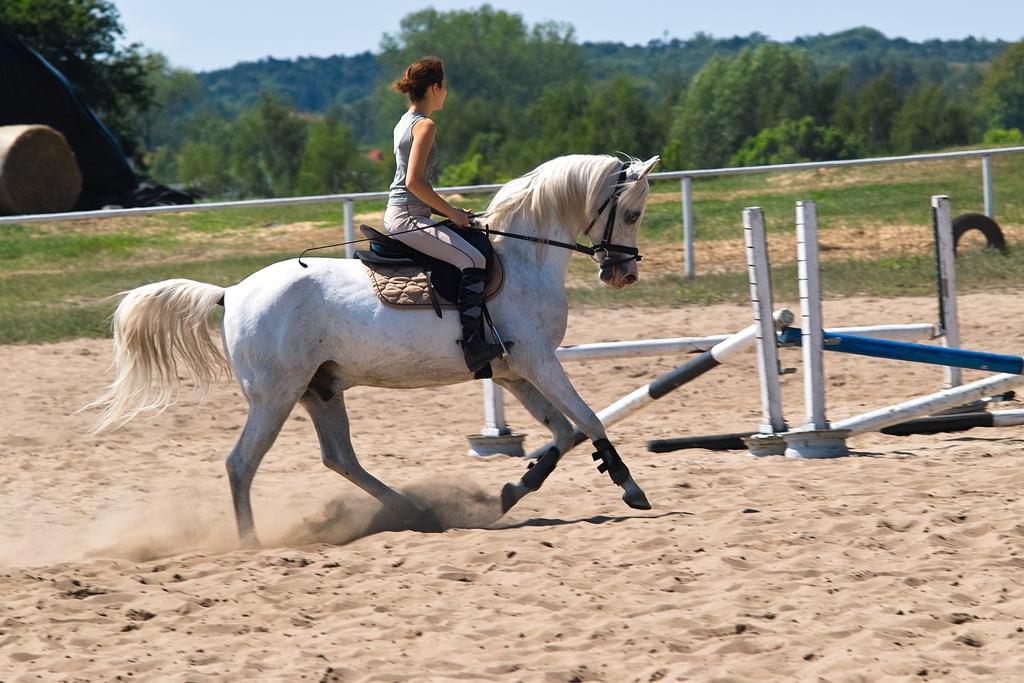Could you give a brief overview of what you see in this image? in this image i can see a white horse rided by a woman. behind them there are many trees and fencing. 